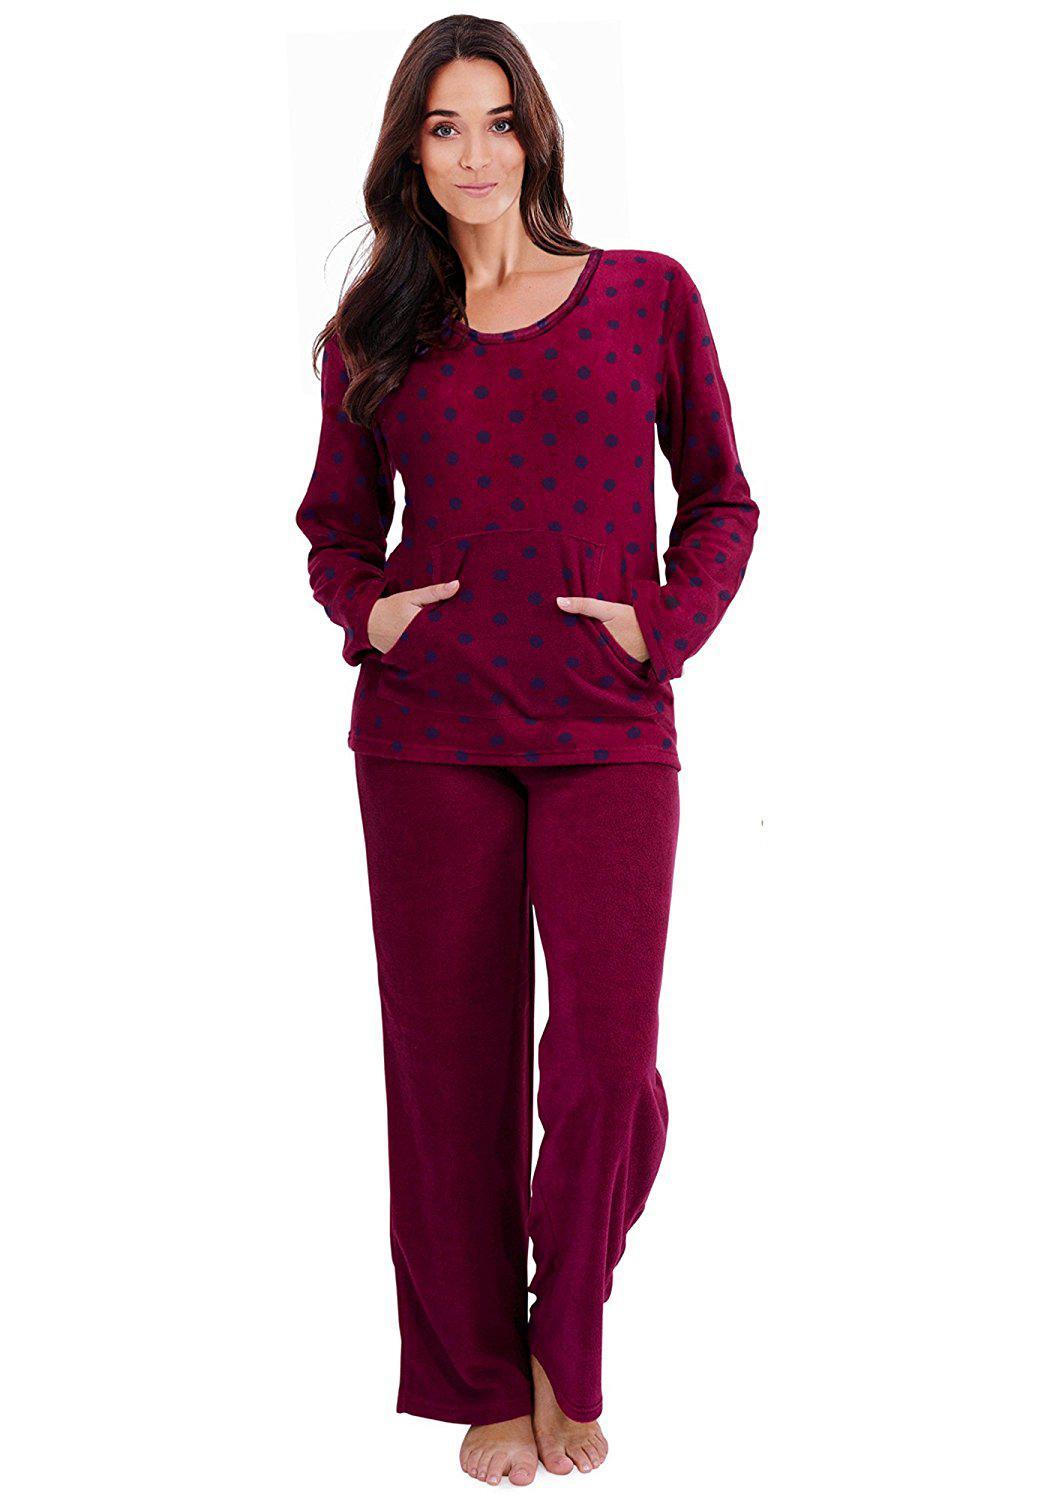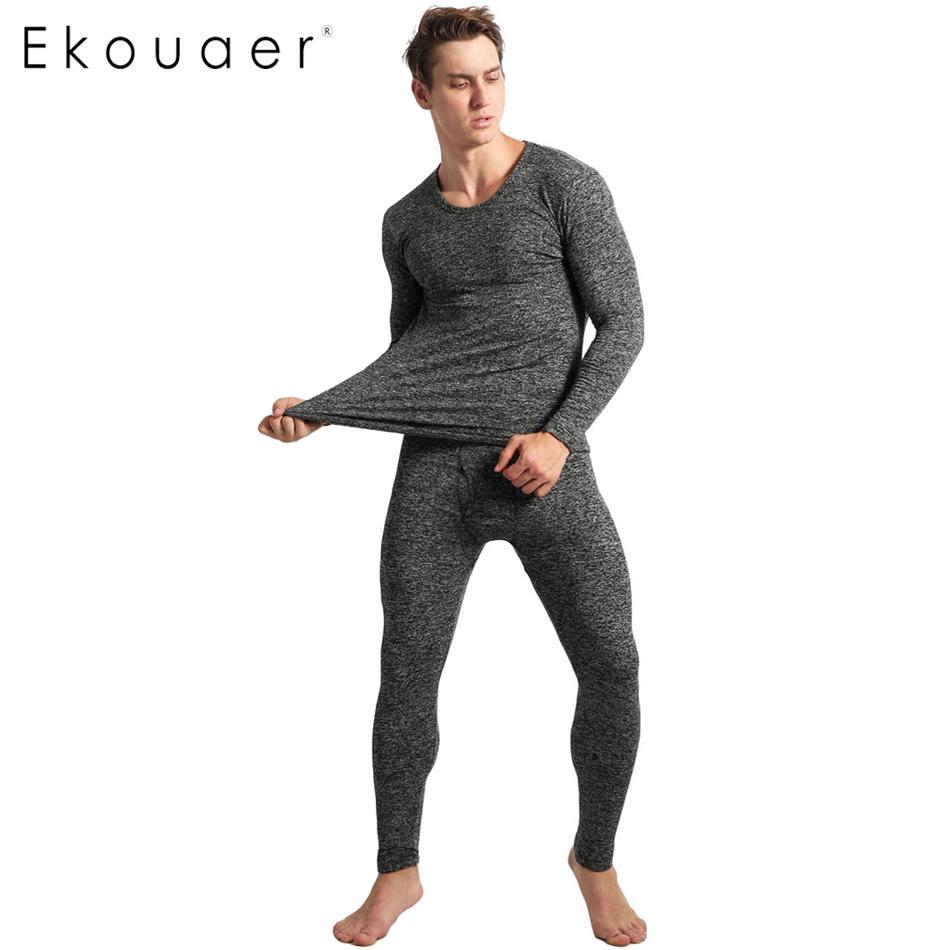The first image is the image on the left, the second image is the image on the right. For the images displayed, is the sentence "There are at least four women in the image on the left." factually correct? Answer yes or no. No. 